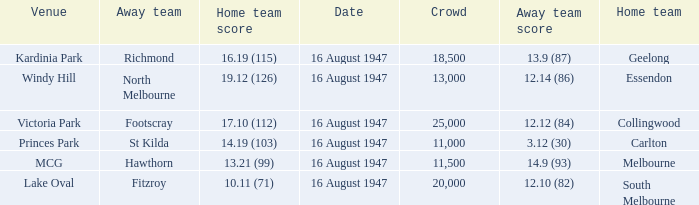What home team has had a crowd bigger than 20,000? Collingwood. 